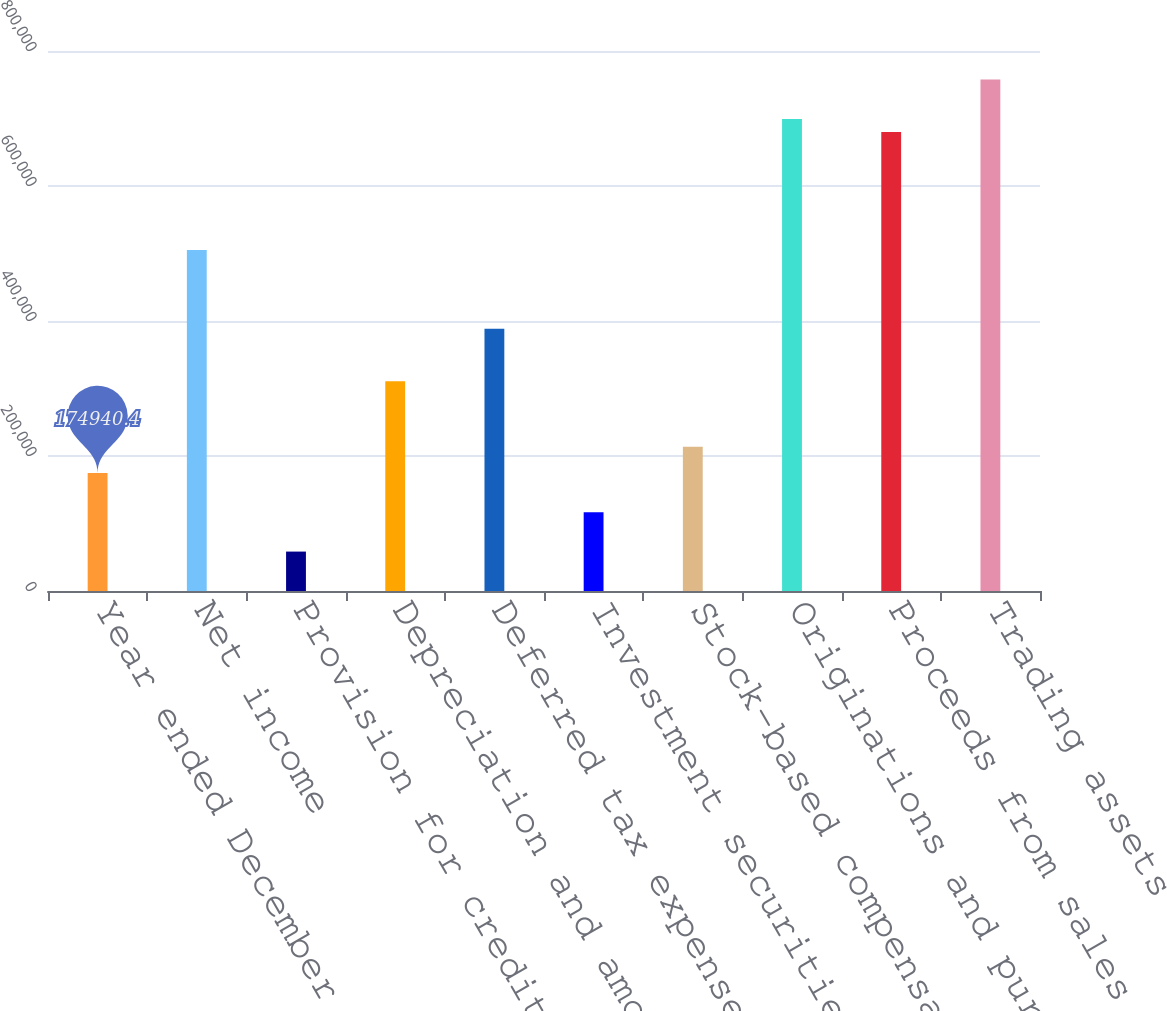<chart> <loc_0><loc_0><loc_500><loc_500><bar_chart><fcel>Year ended December 31 (in<fcel>Net income<fcel>Provision for credit losses<fcel>Depreciation and amortization<fcel>Deferred tax expense<fcel>Investment securities gains<fcel>Stock-based compensation<fcel>Originations and purchases of<fcel>Proceeds from sales<fcel>Trading assets<nl><fcel>174940<fcel>505125<fcel>58404.8<fcel>310899<fcel>388589<fcel>116673<fcel>213786<fcel>699351<fcel>679928<fcel>757618<nl></chart> 